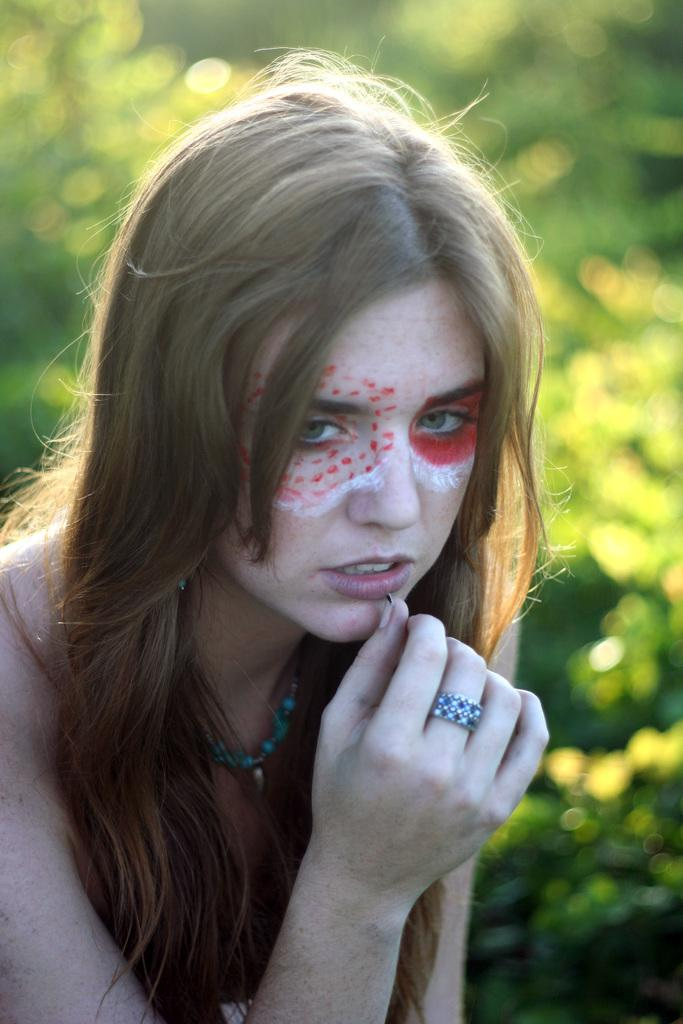Who is the main subject in the foreground of the picture? There is a woman in the foreground of the picture. What can be observed on the woman's face? The woman has makeup on her face. What type of environment is visible in the background of the picture? There is greenery in the background of the picture. What type of lace can be seen on the woman's clothing in the image? There is no lace visible on the woman's clothing in the image. How does the blood on the woman's face affect her makeup in the image? There is no blood present on the woman's face in the image. 